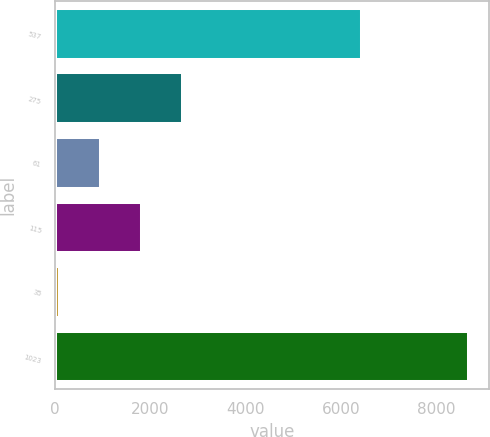Convert chart to OTSL. <chart><loc_0><loc_0><loc_500><loc_500><bar_chart><fcel>537<fcel>275<fcel>61<fcel>115<fcel>35<fcel>1023<nl><fcel>6433.5<fcel>2683.44<fcel>968.68<fcel>1826.06<fcel>111.3<fcel>8685.1<nl></chart> 